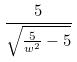<formula> <loc_0><loc_0><loc_500><loc_500>\frac { 5 } { \sqrt { \frac { 5 } { w ^ { 2 } } - 5 } }</formula> 